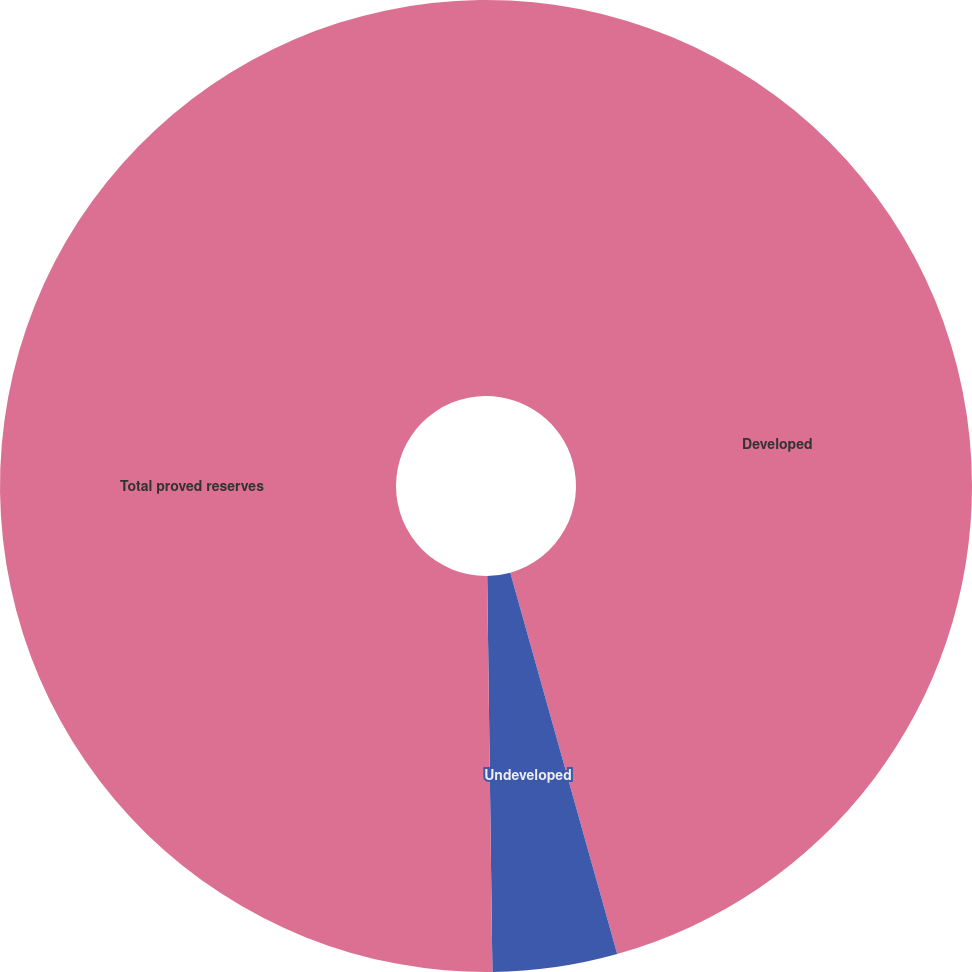Convert chart. <chart><loc_0><loc_0><loc_500><loc_500><pie_chart><fcel>Developed<fcel>Undeveloped<fcel>Total proved reserves<nl><fcel>45.65%<fcel>4.14%<fcel>50.21%<nl></chart> 